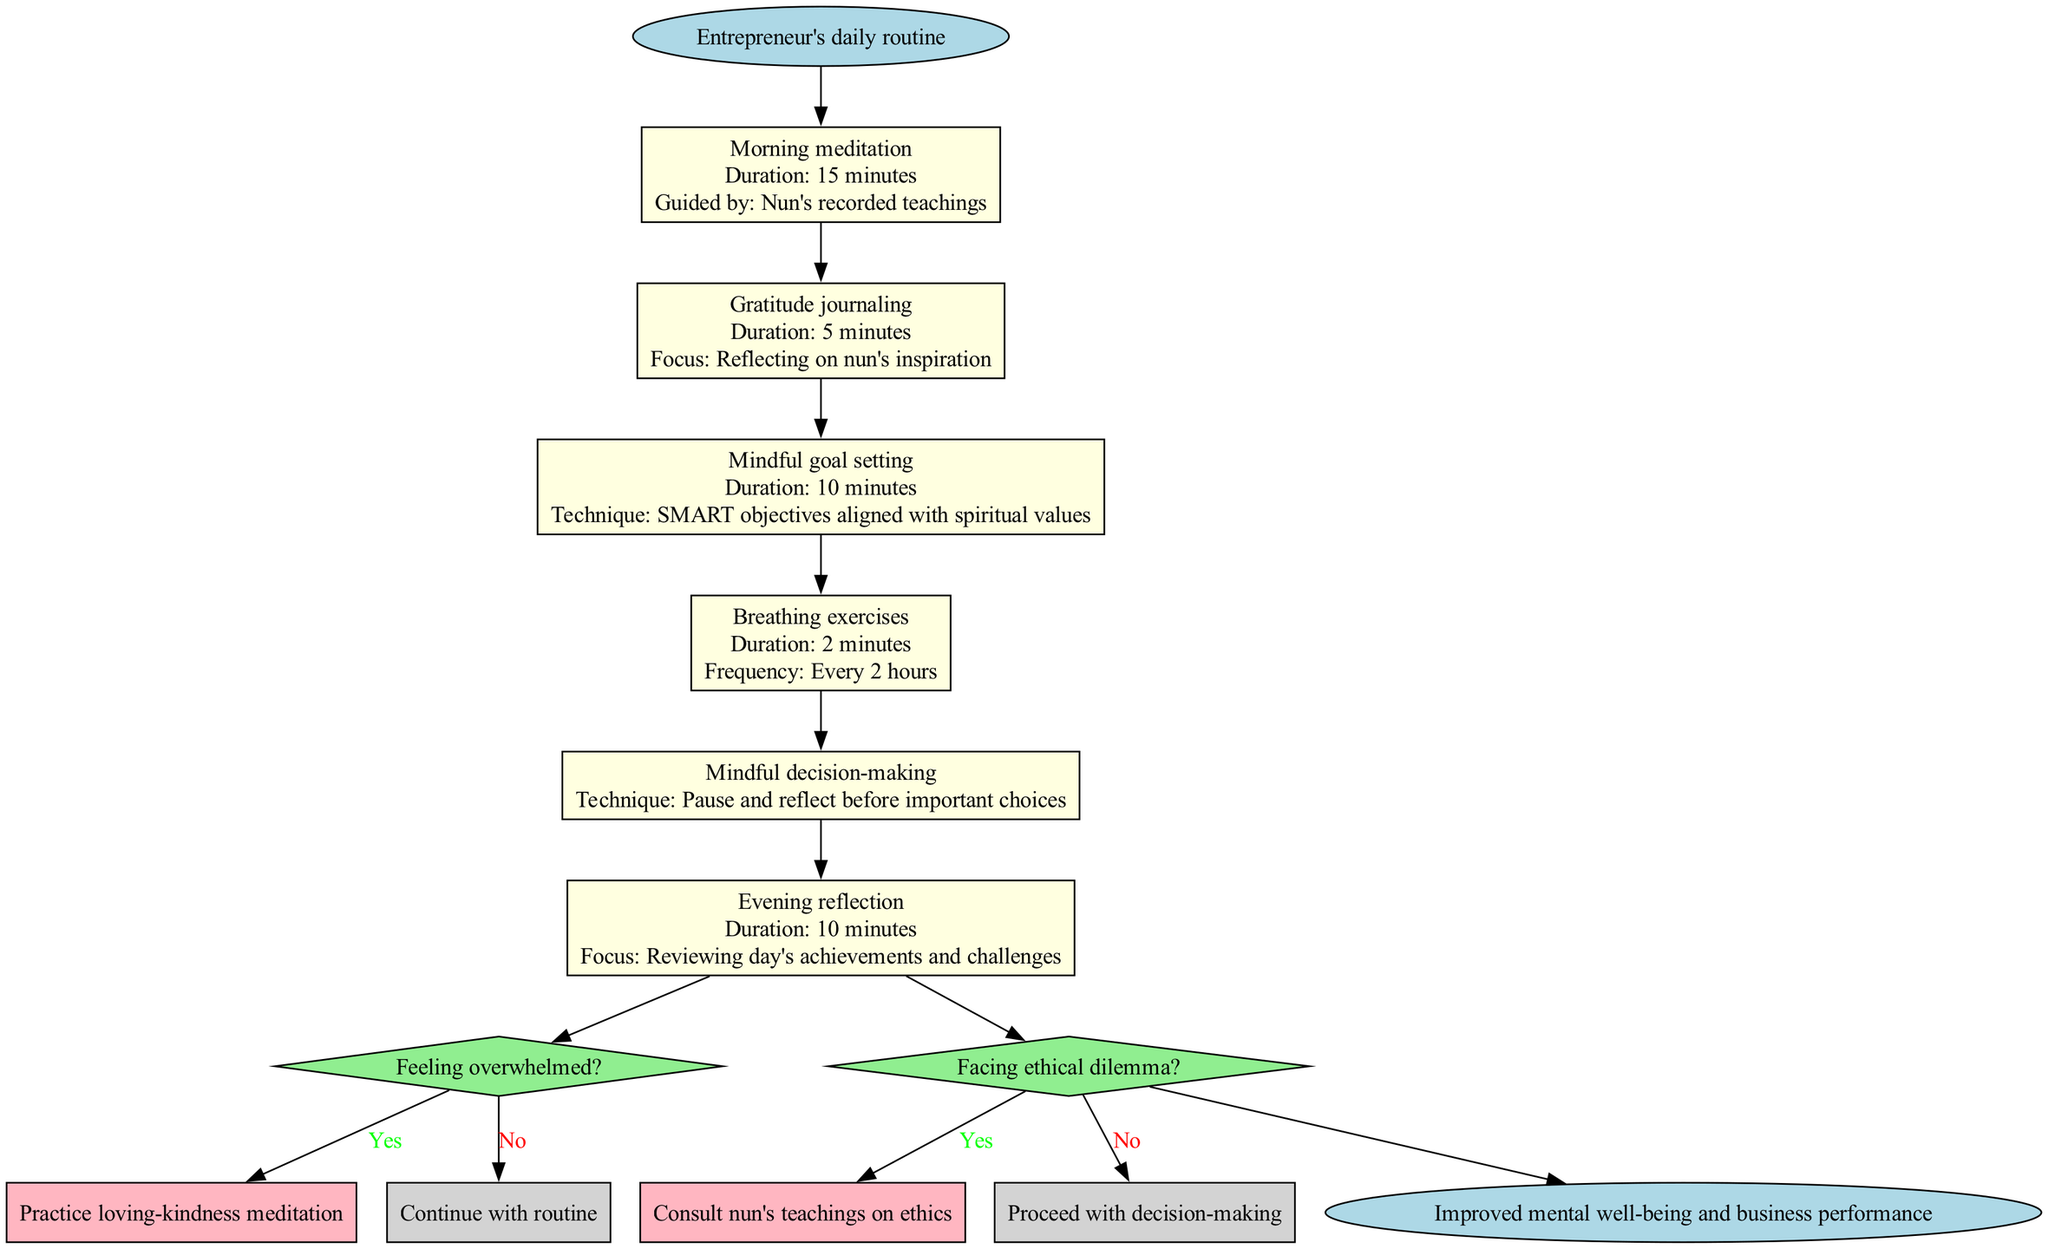What is the first step in the pathway? The first step listed in the diagram is "Morning meditation." This is the initial node after the start point, indicating where the routine begins.
Answer: Morning meditation How long does the evening reflection take? The evening reflection step in the diagram specifies a duration of "10 minutes." This is directly labeled on the corresponding node for that step.
Answer: 10 minutes How often are breathing exercises performed? The diagram states that breathing exercises are performed "Every 2 hours." This frequency is explicitly detailed in the respective node for breathing exercises.
Answer: Every 2 hours What is the condition that leads to practicing loving-kindness meditation? The diagram presents a decision point with the condition "Feeling overwhelmed?" If this condition is met (i.e., the answer is yes), it directs the pathway to practicing loving-kindness meditation.
Answer: Feeling overwhelmed? What is the technique for mindful goal setting? The node for mindful goal setting notes a technique of "SMART objectives aligned with spiritual values." This detail combines the purpose and a specific method for the step in the pathway.
Answer: SMART objectives aligned with spiritual values What happens after facing an ethical dilemma? Upon facing an ethical dilemma, the pathway instructs to "Consult nun's teachings on ethics" if the answer is yes. This direction is a clear response accumulated from tracing the decision point leading from the last step.
Answer: Consult nun's teachings on ethics What are the last two nodes in the pathway? The last two nodes in the pathway are the decision point "Facing ethical dilemma?" and the end node describing "Improved mental well-being and business performance." This corresponds to the terminal points of the diagram's flow.
Answer: Facing ethical dilemma? and Improved mental well-being and business performance Which step focuses on reviewing the day's achievements and challenges? The step dedicated to reviewing the day’s accomplishments and obstacles is named "Evening reflection." This is explicitly identified in the flow of the routine outlined in the diagram.
Answer: Evening reflection What is indicated if the answer to "Feeling overwhelmed?" is no? If the answer to "Feeling overwhelmed?" is no, the pathway indicates to "Continue with routine," suggesting no changes should be made to the established routine.
Answer: Continue with routine 